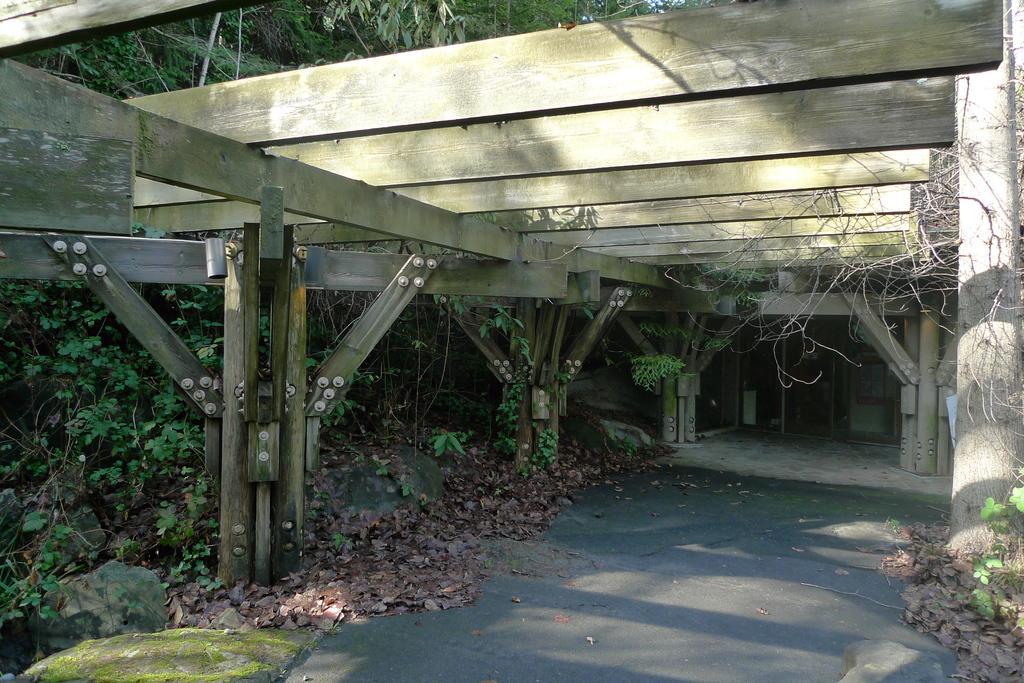Please provide a concise description of this image. This image consists of a road. To the left, there are plants and trees. At the top, there is a bridge made up of wood. 